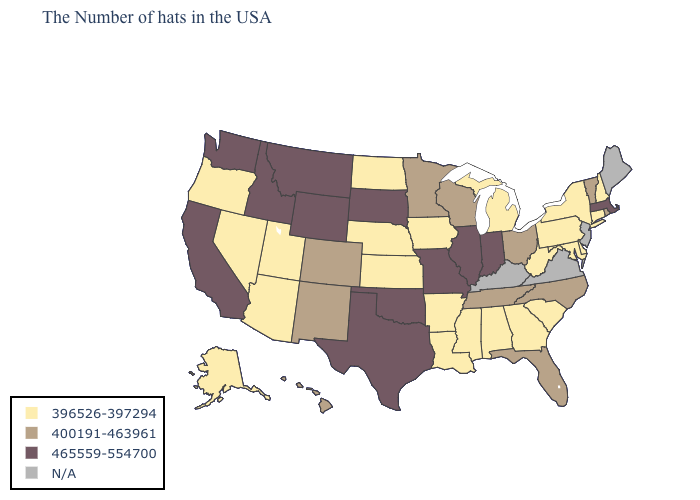What is the lowest value in states that border Utah?
Answer briefly. 396526-397294. Which states have the lowest value in the USA?
Answer briefly. New Hampshire, Connecticut, New York, Delaware, Maryland, Pennsylvania, South Carolina, West Virginia, Georgia, Michigan, Alabama, Mississippi, Louisiana, Arkansas, Iowa, Kansas, Nebraska, North Dakota, Utah, Arizona, Nevada, Oregon, Alaska. Among the states that border Minnesota , which have the lowest value?
Answer briefly. Iowa, North Dakota. Which states have the lowest value in the Northeast?
Keep it brief. New Hampshire, Connecticut, New York, Pennsylvania. What is the value of Ohio?
Keep it brief. 400191-463961. Does the first symbol in the legend represent the smallest category?
Short answer required. Yes. What is the highest value in states that border Indiana?
Give a very brief answer. 465559-554700. Does Alaska have the highest value in the West?
Give a very brief answer. No. Name the states that have a value in the range 396526-397294?
Answer briefly. New Hampshire, Connecticut, New York, Delaware, Maryland, Pennsylvania, South Carolina, West Virginia, Georgia, Michigan, Alabama, Mississippi, Louisiana, Arkansas, Iowa, Kansas, Nebraska, North Dakota, Utah, Arizona, Nevada, Oregon, Alaska. Does Colorado have the highest value in the West?
Write a very short answer. No. What is the value of Georgia?
Concise answer only. 396526-397294. Name the states that have a value in the range 400191-463961?
Short answer required. Rhode Island, Vermont, North Carolina, Ohio, Florida, Tennessee, Wisconsin, Minnesota, Colorado, New Mexico, Hawaii. Which states have the highest value in the USA?
Keep it brief. Massachusetts, Indiana, Illinois, Missouri, Oklahoma, Texas, South Dakota, Wyoming, Montana, Idaho, California, Washington. Name the states that have a value in the range N/A?
Concise answer only. Maine, New Jersey, Virginia, Kentucky. 